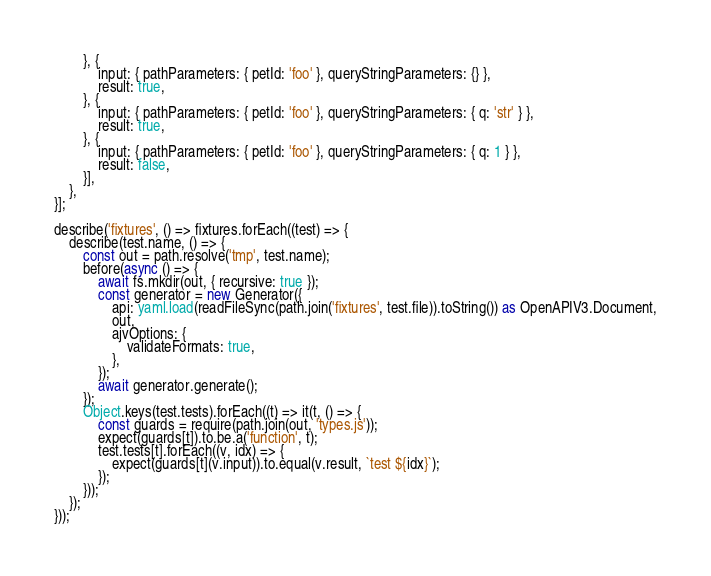Convert code to text. <code><loc_0><loc_0><loc_500><loc_500><_TypeScript_>        }, {
            input: { pathParameters: { petId: 'foo' }, queryStringParameters: {} },
            result: true,
        }, {
            input: { pathParameters: { petId: 'foo' }, queryStringParameters: { q: 'str' } },
            result: true,
        }, {
            input: { pathParameters: { petId: 'foo' }, queryStringParameters: { q: 1 } },
            result: false,
        }],
    },
}];

describe('fixtures', () => fixtures.forEach((test) => {
    describe(test.name, () => {
        const out = path.resolve('tmp', test.name);
        before(async () => {
            await fs.mkdir(out, { recursive: true });
            const generator = new Generator({
                api: yaml.load(readFileSync(path.join('fixtures', test.file)).toString()) as OpenAPIV3.Document,
                out,
                ajvOptions: {
                    validateFormats: true,
                },
            });
            await generator.generate();
        });
        Object.keys(test.tests).forEach((t) => it(t, () => {
            const guards = require(path.join(out, 'types.js'));
            expect(guards[t]).to.be.a('function', t);
            test.tests[t].forEach((v, idx) => {
                expect(guards[t](v.input)).to.equal(v.result, `test ${idx}`);
            });
        }));
    });
}));
</code> 